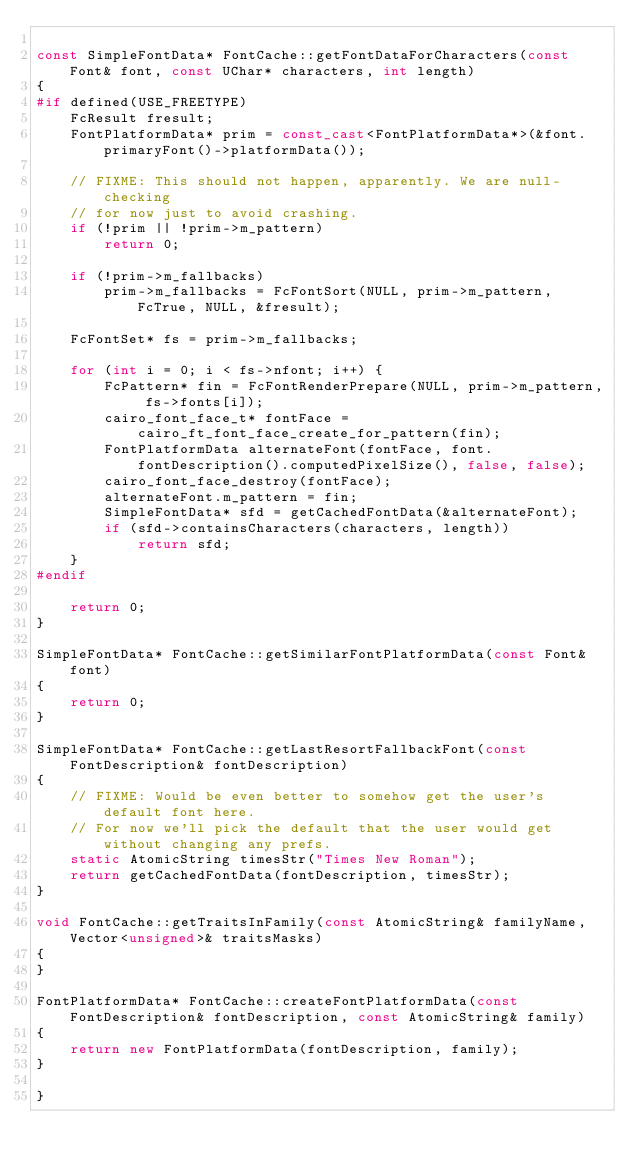<code> <loc_0><loc_0><loc_500><loc_500><_C++_>
const SimpleFontData* FontCache::getFontDataForCharacters(const Font& font, const UChar* characters, int length)
{
#if defined(USE_FREETYPE)
    FcResult fresult;
    FontPlatformData* prim = const_cast<FontPlatformData*>(&font.primaryFont()->platformData());

    // FIXME: This should not happen, apparently. We are null-checking
    // for now just to avoid crashing.
    if (!prim || !prim->m_pattern)
        return 0;

    if (!prim->m_fallbacks)
        prim->m_fallbacks = FcFontSort(NULL, prim->m_pattern, FcTrue, NULL, &fresult);

    FcFontSet* fs = prim->m_fallbacks;

    for (int i = 0; i < fs->nfont; i++) {
        FcPattern* fin = FcFontRenderPrepare(NULL, prim->m_pattern, fs->fonts[i]);
        cairo_font_face_t* fontFace = cairo_ft_font_face_create_for_pattern(fin);
        FontPlatformData alternateFont(fontFace, font.fontDescription().computedPixelSize(), false, false);
        cairo_font_face_destroy(fontFace);
        alternateFont.m_pattern = fin;
        SimpleFontData* sfd = getCachedFontData(&alternateFont);
        if (sfd->containsCharacters(characters, length))
            return sfd;
    }
#endif

    return 0;
}

SimpleFontData* FontCache::getSimilarFontPlatformData(const Font& font)
{
    return 0;
}

SimpleFontData* FontCache::getLastResortFallbackFont(const FontDescription& fontDescription)
{
    // FIXME: Would be even better to somehow get the user's default font here.
    // For now we'll pick the default that the user would get without changing any prefs.
    static AtomicString timesStr("Times New Roman");
    return getCachedFontData(fontDescription, timesStr);
}

void FontCache::getTraitsInFamily(const AtomicString& familyName, Vector<unsigned>& traitsMasks)
{
}

FontPlatformData* FontCache::createFontPlatformData(const FontDescription& fontDescription, const AtomicString& family)
{
    return new FontPlatformData(fontDescription, family);
}

}
</code> 